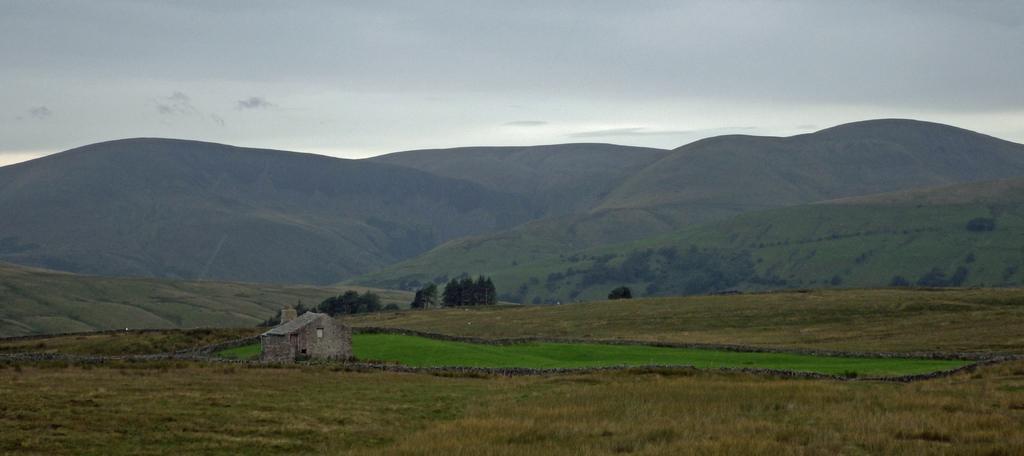How would you summarize this image in a sentence or two? In this image there is house, plants, grass, trees, hills, sky. 